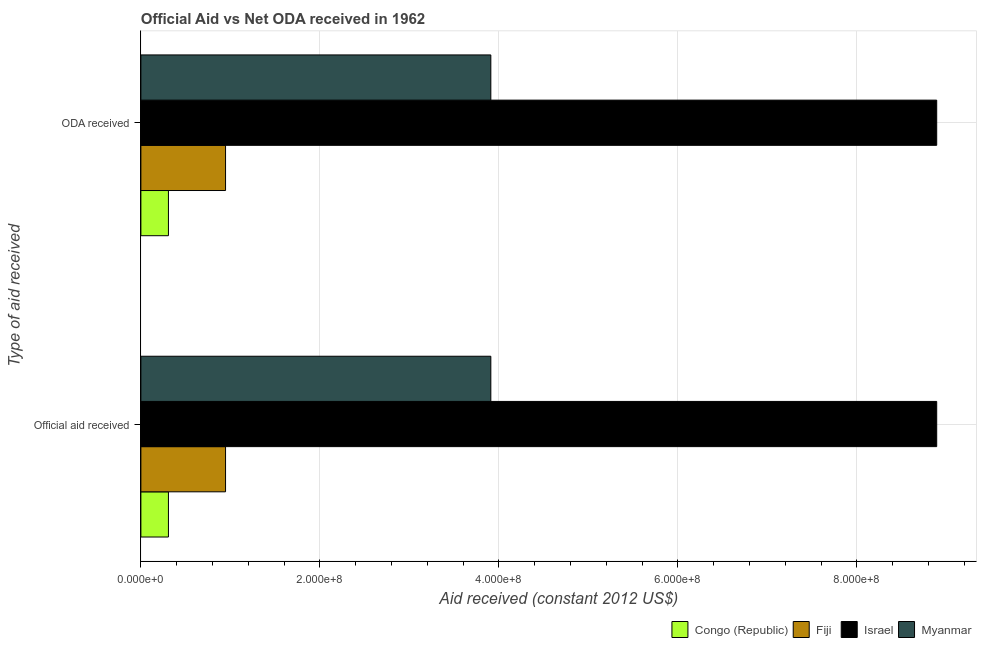How many different coloured bars are there?
Your answer should be compact. 4. How many groups of bars are there?
Offer a terse response. 2. How many bars are there on the 1st tick from the top?
Your answer should be compact. 4. How many bars are there on the 2nd tick from the bottom?
Provide a succinct answer. 4. What is the label of the 2nd group of bars from the top?
Your response must be concise. Official aid received. What is the oda received in Fiji?
Your answer should be very brief. 9.46e+07. Across all countries, what is the maximum oda received?
Offer a terse response. 8.89e+08. Across all countries, what is the minimum oda received?
Offer a very short reply. 3.08e+07. In which country was the oda received maximum?
Offer a very short reply. Israel. In which country was the official aid received minimum?
Your answer should be compact. Congo (Republic). What is the total oda received in the graph?
Make the answer very short. 1.41e+09. What is the difference between the oda received in Congo (Republic) and that in Israel?
Keep it short and to the point. -8.58e+08. What is the difference between the official aid received in Congo (Republic) and the oda received in Myanmar?
Offer a terse response. -3.60e+08. What is the average oda received per country?
Your answer should be compact. 3.51e+08. In how many countries, is the oda received greater than 560000000 US$?
Offer a very short reply. 1. What is the ratio of the oda received in Congo (Republic) to that in Myanmar?
Ensure brevity in your answer.  0.08. What does the 2nd bar from the top in Official aid received represents?
Give a very brief answer. Israel. What does the 2nd bar from the bottom in ODA received represents?
Ensure brevity in your answer.  Fiji. How many bars are there?
Your answer should be very brief. 8. How many countries are there in the graph?
Ensure brevity in your answer.  4. Are the values on the major ticks of X-axis written in scientific E-notation?
Your answer should be very brief. Yes. Does the graph contain any zero values?
Your response must be concise. No. How are the legend labels stacked?
Provide a succinct answer. Horizontal. What is the title of the graph?
Ensure brevity in your answer.  Official Aid vs Net ODA received in 1962 . What is the label or title of the X-axis?
Give a very brief answer. Aid received (constant 2012 US$). What is the label or title of the Y-axis?
Ensure brevity in your answer.  Type of aid received. What is the Aid received (constant 2012 US$) in Congo (Republic) in Official aid received?
Provide a short and direct response. 3.08e+07. What is the Aid received (constant 2012 US$) of Fiji in Official aid received?
Offer a very short reply. 9.46e+07. What is the Aid received (constant 2012 US$) in Israel in Official aid received?
Ensure brevity in your answer.  8.89e+08. What is the Aid received (constant 2012 US$) of Myanmar in Official aid received?
Give a very brief answer. 3.91e+08. What is the Aid received (constant 2012 US$) of Congo (Republic) in ODA received?
Your answer should be very brief. 3.08e+07. What is the Aid received (constant 2012 US$) in Fiji in ODA received?
Give a very brief answer. 9.46e+07. What is the Aid received (constant 2012 US$) of Israel in ODA received?
Your answer should be very brief. 8.89e+08. What is the Aid received (constant 2012 US$) in Myanmar in ODA received?
Your answer should be very brief. 3.91e+08. Across all Type of aid received, what is the maximum Aid received (constant 2012 US$) in Congo (Republic)?
Make the answer very short. 3.08e+07. Across all Type of aid received, what is the maximum Aid received (constant 2012 US$) in Fiji?
Your response must be concise. 9.46e+07. Across all Type of aid received, what is the maximum Aid received (constant 2012 US$) in Israel?
Ensure brevity in your answer.  8.89e+08. Across all Type of aid received, what is the maximum Aid received (constant 2012 US$) in Myanmar?
Provide a short and direct response. 3.91e+08. Across all Type of aid received, what is the minimum Aid received (constant 2012 US$) in Congo (Republic)?
Your response must be concise. 3.08e+07. Across all Type of aid received, what is the minimum Aid received (constant 2012 US$) in Fiji?
Provide a succinct answer. 9.46e+07. Across all Type of aid received, what is the minimum Aid received (constant 2012 US$) in Israel?
Provide a succinct answer. 8.89e+08. Across all Type of aid received, what is the minimum Aid received (constant 2012 US$) in Myanmar?
Offer a terse response. 3.91e+08. What is the total Aid received (constant 2012 US$) in Congo (Republic) in the graph?
Give a very brief answer. 6.16e+07. What is the total Aid received (constant 2012 US$) in Fiji in the graph?
Your answer should be very brief. 1.89e+08. What is the total Aid received (constant 2012 US$) in Israel in the graph?
Your answer should be compact. 1.78e+09. What is the total Aid received (constant 2012 US$) of Myanmar in the graph?
Provide a succinct answer. 7.82e+08. What is the difference between the Aid received (constant 2012 US$) of Congo (Republic) in Official aid received and that in ODA received?
Your response must be concise. 0. What is the difference between the Aid received (constant 2012 US$) in Myanmar in Official aid received and that in ODA received?
Give a very brief answer. 0. What is the difference between the Aid received (constant 2012 US$) of Congo (Republic) in Official aid received and the Aid received (constant 2012 US$) of Fiji in ODA received?
Keep it short and to the point. -6.38e+07. What is the difference between the Aid received (constant 2012 US$) of Congo (Republic) in Official aid received and the Aid received (constant 2012 US$) of Israel in ODA received?
Make the answer very short. -8.58e+08. What is the difference between the Aid received (constant 2012 US$) in Congo (Republic) in Official aid received and the Aid received (constant 2012 US$) in Myanmar in ODA received?
Provide a short and direct response. -3.60e+08. What is the difference between the Aid received (constant 2012 US$) of Fiji in Official aid received and the Aid received (constant 2012 US$) of Israel in ODA received?
Ensure brevity in your answer.  -7.95e+08. What is the difference between the Aid received (constant 2012 US$) of Fiji in Official aid received and the Aid received (constant 2012 US$) of Myanmar in ODA received?
Make the answer very short. -2.96e+08. What is the difference between the Aid received (constant 2012 US$) of Israel in Official aid received and the Aid received (constant 2012 US$) of Myanmar in ODA received?
Make the answer very short. 4.98e+08. What is the average Aid received (constant 2012 US$) of Congo (Republic) per Type of aid received?
Ensure brevity in your answer.  3.08e+07. What is the average Aid received (constant 2012 US$) in Fiji per Type of aid received?
Keep it short and to the point. 9.46e+07. What is the average Aid received (constant 2012 US$) of Israel per Type of aid received?
Provide a succinct answer. 8.89e+08. What is the average Aid received (constant 2012 US$) of Myanmar per Type of aid received?
Provide a short and direct response. 3.91e+08. What is the difference between the Aid received (constant 2012 US$) in Congo (Republic) and Aid received (constant 2012 US$) in Fiji in Official aid received?
Your answer should be very brief. -6.38e+07. What is the difference between the Aid received (constant 2012 US$) in Congo (Republic) and Aid received (constant 2012 US$) in Israel in Official aid received?
Your answer should be compact. -8.58e+08. What is the difference between the Aid received (constant 2012 US$) in Congo (Republic) and Aid received (constant 2012 US$) in Myanmar in Official aid received?
Your response must be concise. -3.60e+08. What is the difference between the Aid received (constant 2012 US$) of Fiji and Aid received (constant 2012 US$) of Israel in Official aid received?
Offer a terse response. -7.95e+08. What is the difference between the Aid received (constant 2012 US$) in Fiji and Aid received (constant 2012 US$) in Myanmar in Official aid received?
Keep it short and to the point. -2.96e+08. What is the difference between the Aid received (constant 2012 US$) in Israel and Aid received (constant 2012 US$) in Myanmar in Official aid received?
Give a very brief answer. 4.98e+08. What is the difference between the Aid received (constant 2012 US$) of Congo (Republic) and Aid received (constant 2012 US$) of Fiji in ODA received?
Keep it short and to the point. -6.38e+07. What is the difference between the Aid received (constant 2012 US$) in Congo (Republic) and Aid received (constant 2012 US$) in Israel in ODA received?
Offer a very short reply. -8.58e+08. What is the difference between the Aid received (constant 2012 US$) in Congo (Republic) and Aid received (constant 2012 US$) in Myanmar in ODA received?
Offer a very short reply. -3.60e+08. What is the difference between the Aid received (constant 2012 US$) of Fiji and Aid received (constant 2012 US$) of Israel in ODA received?
Your response must be concise. -7.95e+08. What is the difference between the Aid received (constant 2012 US$) in Fiji and Aid received (constant 2012 US$) in Myanmar in ODA received?
Your response must be concise. -2.96e+08. What is the difference between the Aid received (constant 2012 US$) of Israel and Aid received (constant 2012 US$) of Myanmar in ODA received?
Offer a very short reply. 4.98e+08. What is the ratio of the Aid received (constant 2012 US$) in Myanmar in Official aid received to that in ODA received?
Provide a succinct answer. 1. What is the difference between the highest and the second highest Aid received (constant 2012 US$) of Congo (Republic)?
Offer a very short reply. 0. What is the difference between the highest and the second highest Aid received (constant 2012 US$) of Israel?
Make the answer very short. 0. What is the difference between the highest and the lowest Aid received (constant 2012 US$) in Congo (Republic)?
Offer a terse response. 0. What is the difference between the highest and the lowest Aid received (constant 2012 US$) in Fiji?
Offer a very short reply. 0. What is the difference between the highest and the lowest Aid received (constant 2012 US$) in Myanmar?
Your answer should be compact. 0. 